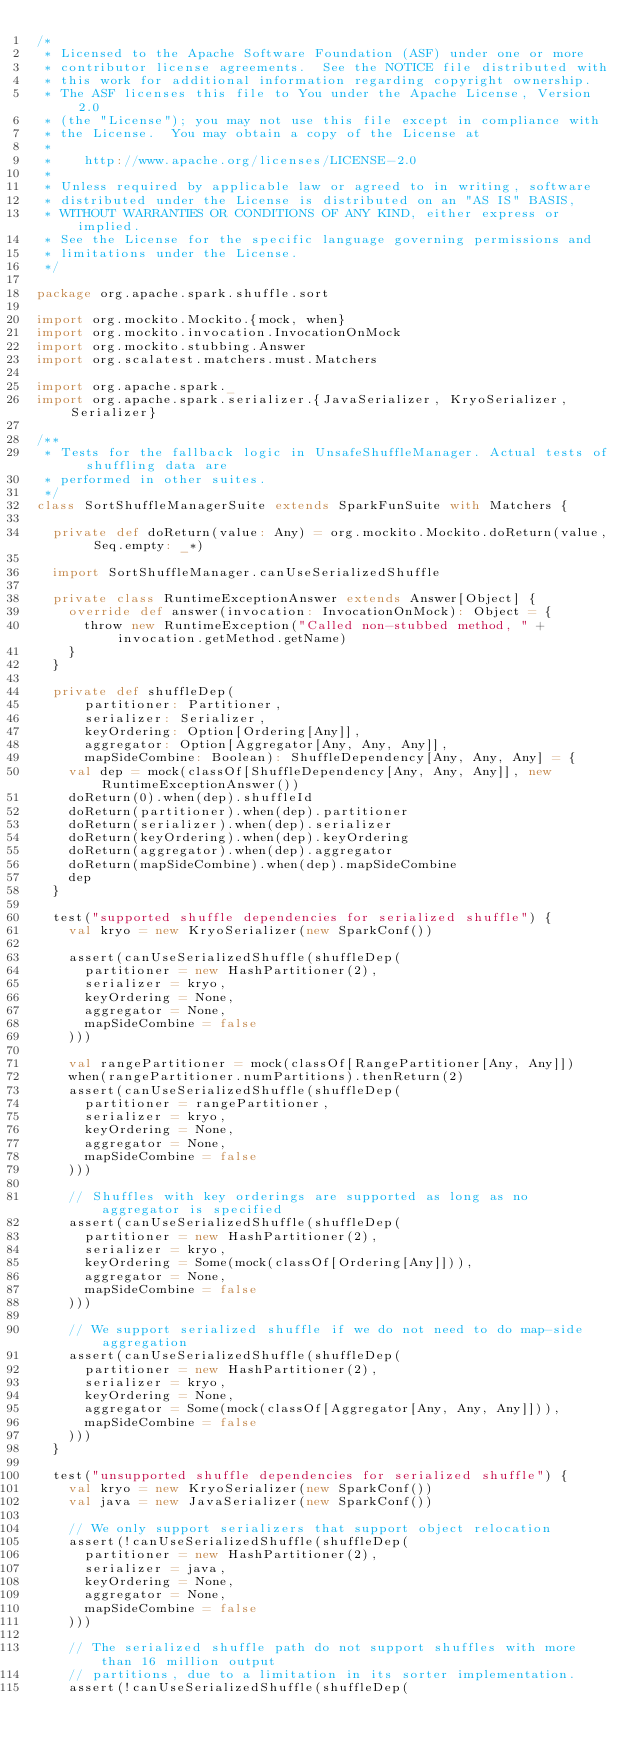Convert code to text. <code><loc_0><loc_0><loc_500><loc_500><_Scala_>/*
 * Licensed to the Apache Software Foundation (ASF) under one or more
 * contributor license agreements.  See the NOTICE file distributed with
 * this work for additional information regarding copyright ownership.
 * The ASF licenses this file to You under the Apache License, Version 2.0
 * (the "License"); you may not use this file except in compliance with
 * the License.  You may obtain a copy of the License at
 *
 *    http://www.apache.org/licenses/LICENSE-2.0
 *
 * Unless required by applicable law or agreed to in writing, software
 * distributed under the License is distributed on an "AS IS" BASIS,
 * WITHOUT WARRANTIES OR CONDITIONS OF ANY KIND, either express or implied.
 * See the License for the specific language governing permissions and
 * limitations under the License.
 */

package org.apache.spark.shuffle.sort

import org.mockito.Mockito.{mock, when}
import org.mockito.invocation.InvocationOnMock
import org.mockito.stubbing.Answer
import org.scalatest.matchers.must.Matchers

import org.apache.spark._
import org.apache.spark.serializer.{JavaSerializer, KryoSerializer, Serializer}

/**
 * Tests for the fallback logic in UnsafeShuffleManager. Actual tests of shuffling data are
 * performed in other suites.
 */
class SortShuffleManagerSuite extends SparkFunSuite with Matchers {

  private def doReturn(value: Any) = org.mockito.Mockito.doReturn(value, Seq.empty: _*)

  import SortShuffleManager.canUseSerializedShuffle

  private class RuntimeExceptionAnswer extends Answer[Object] {
    override def answer(invocation: InvocationOnMock): Object = {
      throw new RuntimeException("Called non-stubbed method, " + invocation.getMethod.getName)
    }
  }

  private def shuffleDep(
      partitioner: Partitioner,
      serializer: Serializer,
      keyOrdering: Option[Ordering[Any]],
      aggregator: Option[Aggregator[Any, Any, Any]],
      mapSideCombine: Boolean): ShuffleDependency[Any, Any, Any] = {
    val dep = mock(classOf[ShuffleDependency[Any, Any, Any]], new RuntimeExceptionAnswer())
    doReturn(0).when(dep).shuffleId
    doReturn(partitioner).when(dep).partitioner
    doReturn(serializer).when(dep).serializer
    doReturn(keyOrdering).when(dep).keyOrdering
    doReturn(aggregator).when(dep).aggregator
    doReturn(mapSideCombine).when(dep).mapSideCombine
    dep
  }

  test("supported shuffle dependencies for serialized shuffle") {
    val kryo = new KryoSerializer(new SparkConf())

    assert(canUseSerializedShuffle(shuffleDep(
      partitioner = new HashPartitioner(2),
      serializer = kryo,
      keyOrdering = None,
      aggregator = None,
      mapSideCombine = false
    )))

    val rangePartitioner = mock(classOf[RangePartitioner[Any, Any]])
    when(rangePartitioner.numPartitions).thenReturn(2)
    assert(canUseSerializedShuffle(shuffleDep(
      partitioner = rangePartitioner,
      serializer = kryo,
      keyOrdering = None,
      aggregator = None,
      mapSideCombine = false
    )))

    // Shuffles with key orderings are supported as long as no aggregator is specified
    assert(canUseSerializedShuffle(shuffleDep(
      partitioner = new HashPartitioner(2),
      serializer = kryo,
      keyOrdering = Some(mock(classOf[Ordering[Any]])),
      aggregator = None,
      mapSideCombine = false
    )))

    // We support serialized shuffle if we do not need to do map-side aggregation
    assert(canUseSerializedShuffle(shuffleDep(
      partitioner = new HashPartitioner(2),
      serializer = kryo,
      keyOrdering = None,
      aggregator = Some(mock(classOf[Aggregator[Any, Any, Any]])),
      mapSideCombine = false
    )))
  }

  test("unsupported shuffle dependencies for serialized shuffle") {
    val kryo = new KryoSerializer(new SparkConf())
    val java = new JavaSerializer(new SparkConf())

    // We only support serializers that support object relocation
    assert(!canUseSerializedShuffle(shuffleDep(
      partitioner = new HashPartitioner(2),
      serializer = java,
      keyOrdering = None,
      aggregator = None,
      mapSideCombine = false
    )))

    // The serialized shuffle path do not support shuffles with more than 16 million output
    // partitions, due to a limitation in its sorter implementation.
    assert(!canUseSerializedShuffle(shuffleDep(</code> 